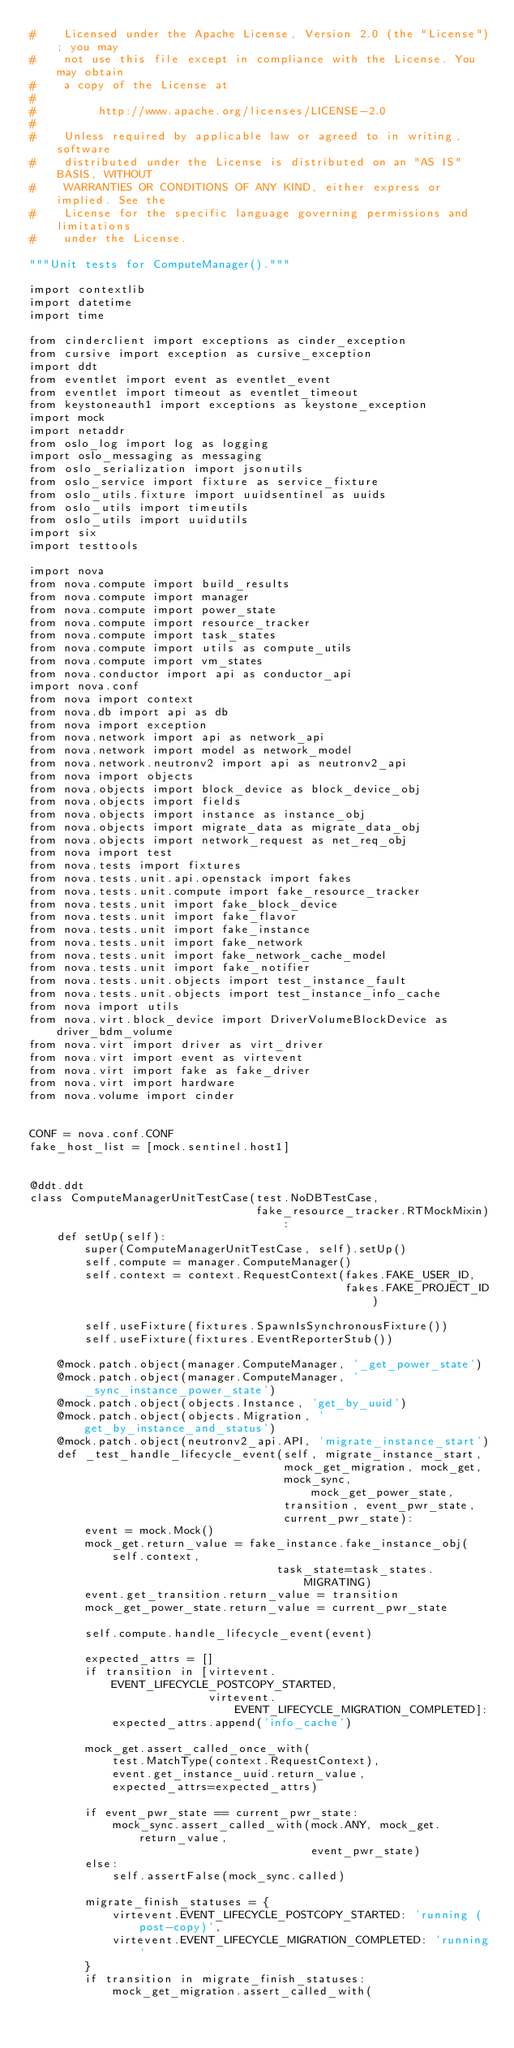<code> <loc_0><loc_0><loc_500><loc_500><_Python_>#    Licensed under the Apache License, Version 2.0 (the "License"); you may
#    not use this file except in compliance with the License. You may obtain
#    a copy of the License at
#
#         http://www.apache.org/licenses/LICENSE-2.0
#
#    Unless required by applicable law or agreed to in writing, software
#    distributed under the License is distributed on an "AS IS" BASIS, WITHOUT
#    WARRANTIES OR CONDITIONS OF ANY KIND, either express or implied. See the
#    License for the specific language governing permissions and limitations
#    under the License.

"""Unit tests for ComputeManager()."""

import contextlib
import datetime
import time

from cinderclient import exceptions as cinder_exception
from cursive import exception as cursive_exception
import ddt
from eventlet import event as eventlet_event
from eventlet import timeout as eventlet_timeout
from keystoneauth1 import exceptions as keystone_exception
import mock
import netaddr
from oslo_log import log as logging
import oslo_messaging as messaging
from oslo_serialization import jsonutils
from oslo_service import fixture as service_fixture
from oslo_utils.fixture import uuidsentinel as uuids
from oslo_utils import timeutils
from oslo_utils import uuidutils
import six
import testtools

import nova
from nova.compute import build_results
from nova.compute import manager
from nova.compute import power_state
from nova.compute import resource_tracker
from nova.compute import task_states
from nova.compute import utils as compute_utils
from nova.compute import vm_states
from nova.conductor import api as conductor_api
import nova.conf
from nova import context
from nova.db import api as db
from nova import exception
from nova.network import api as network_api
from nova.network import model as network_model
from nova.network.neutronv2 import api as neutronv2_api
from nova import objects
from nova.objects import block_device as block_device_obj
from nova.objects import fields
from nova.objects import instance as instance_obj
from nova.objects import migrate_data as migrate_data_obj
from nova.objects import network_request as net_req_obj
from nova import test
from nova.tests import fixtures
from nova.tests.unit.api.openstack import fakes
from nova.tests.unit.compute import fake_resource_tracker
from nova.tests.unit import fake_block_device
from nova.tests.unit import fake_flavor
from nova.tests.unit import fake_instance
from nova.tests.unit import fake_network
from nova.tests.unit import fake_network_cache_model
from nova.tests.unit import fake_notifier
from nova.tests.unit.objects import test_instance_fault
from nova.tests.unit.objects import test_instance_info_cache
from nova import utils
from nova.virt.block_device import DriverVolumeBlockDevice as driver_bdm_volume
from nova.virt import driver as virt_driver
from nova.virt import event as virtevent
from nova.virt import fake as fake_driver
from nova.virt import hardware
from nova.volume import cinder


CONF = nova.conf.CONF
fake_host_list = [mock.sentinel.host1]


@ddt.ddt
class ComputeManagerUnitTestCase(test.NoDBTestCase,
                                 fake_resource_tracker.RTMockMixin):
    def setUp(self):
        super(ComputeManagerUnitTestCase, self).setUp()
        self.compute = manager.ComputeManager()
        self.context = context.RequestContext(fakes.FAKE_USER_ID,
                                              fakes.FAKE_PROJECT_ID)

        self.useFixture(fixtures.SpawnIsSynchronousFixture())
        self.useFixture(fixtures.EventReporterStub())

    @mock.patch.object(manager.ComputeManager, '_get_power_state')
    @mock.patch.object(manager.ComputeManager, '_sync_instance_power_state')
    @mock.patch.object(objects.Instance, 'get_by_uuid')
    @mock.patch.object(objects.Migration, 'get_by_instance_and_status')
    @mock.patch.object(neutronv2_api.API, 'migrate_instance_start')
    def _test_handle_lifecycle_event(self, migrate_instance_start,
                                     mock_get_migration, mock_get,
                                     mock_sync, mock_get_power_state,
                                     transition, event_pwr_state,
                                     current_pwr_state):
        event = mock.Mock()
        mock_get.return_value = fake_instance.fake_instance_obj(self.context,
                                    task_state=task_states.MIGRATING)
        event.get_transition.return_value = transition
        mock_get_power_state.return_value = current_pwr_state

        self.compute.handle_lifecycle_event(event)

        expected_attrs = []
        if transition in [virtevent.EVENT_LIFECYCLE_POSTCOPY_STARTED,
                          virtevent.EVENT_LIFECYCLE_MIGRATION_COMPLETED]:
            expected_attrs.append('info_cache')

        mock_get.assert_called_once_with(
            test.MatchType(context.RequestContext),
            event.get_instance_uuid.return_value,
            expected_attrs=expected_attrs)

        if event_pwr_state == current_pwr_state:
            mock_sync.assert_called_with(mock.ANY, mock_get.return_value,
                                         event_pwr_state)
        else:
            self.assertFalse(mock_sync.called)

        migrate_finish_statuses = {
            virtevent.EVENT_LIFECYCLE_POSTCOPY_STARTED: 'running (post-copy)',
            virtevent.EVENT_LIFECYCLE_MIGRATION_COMPLETED: 'running'
        }
        if transition in migrate_finish_statuses:
            mock_get_migration.assert_called_with(</code> 